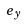<formula> <loc_0><loc_0><loc_500><loc_500>e _ { y }</formula> 